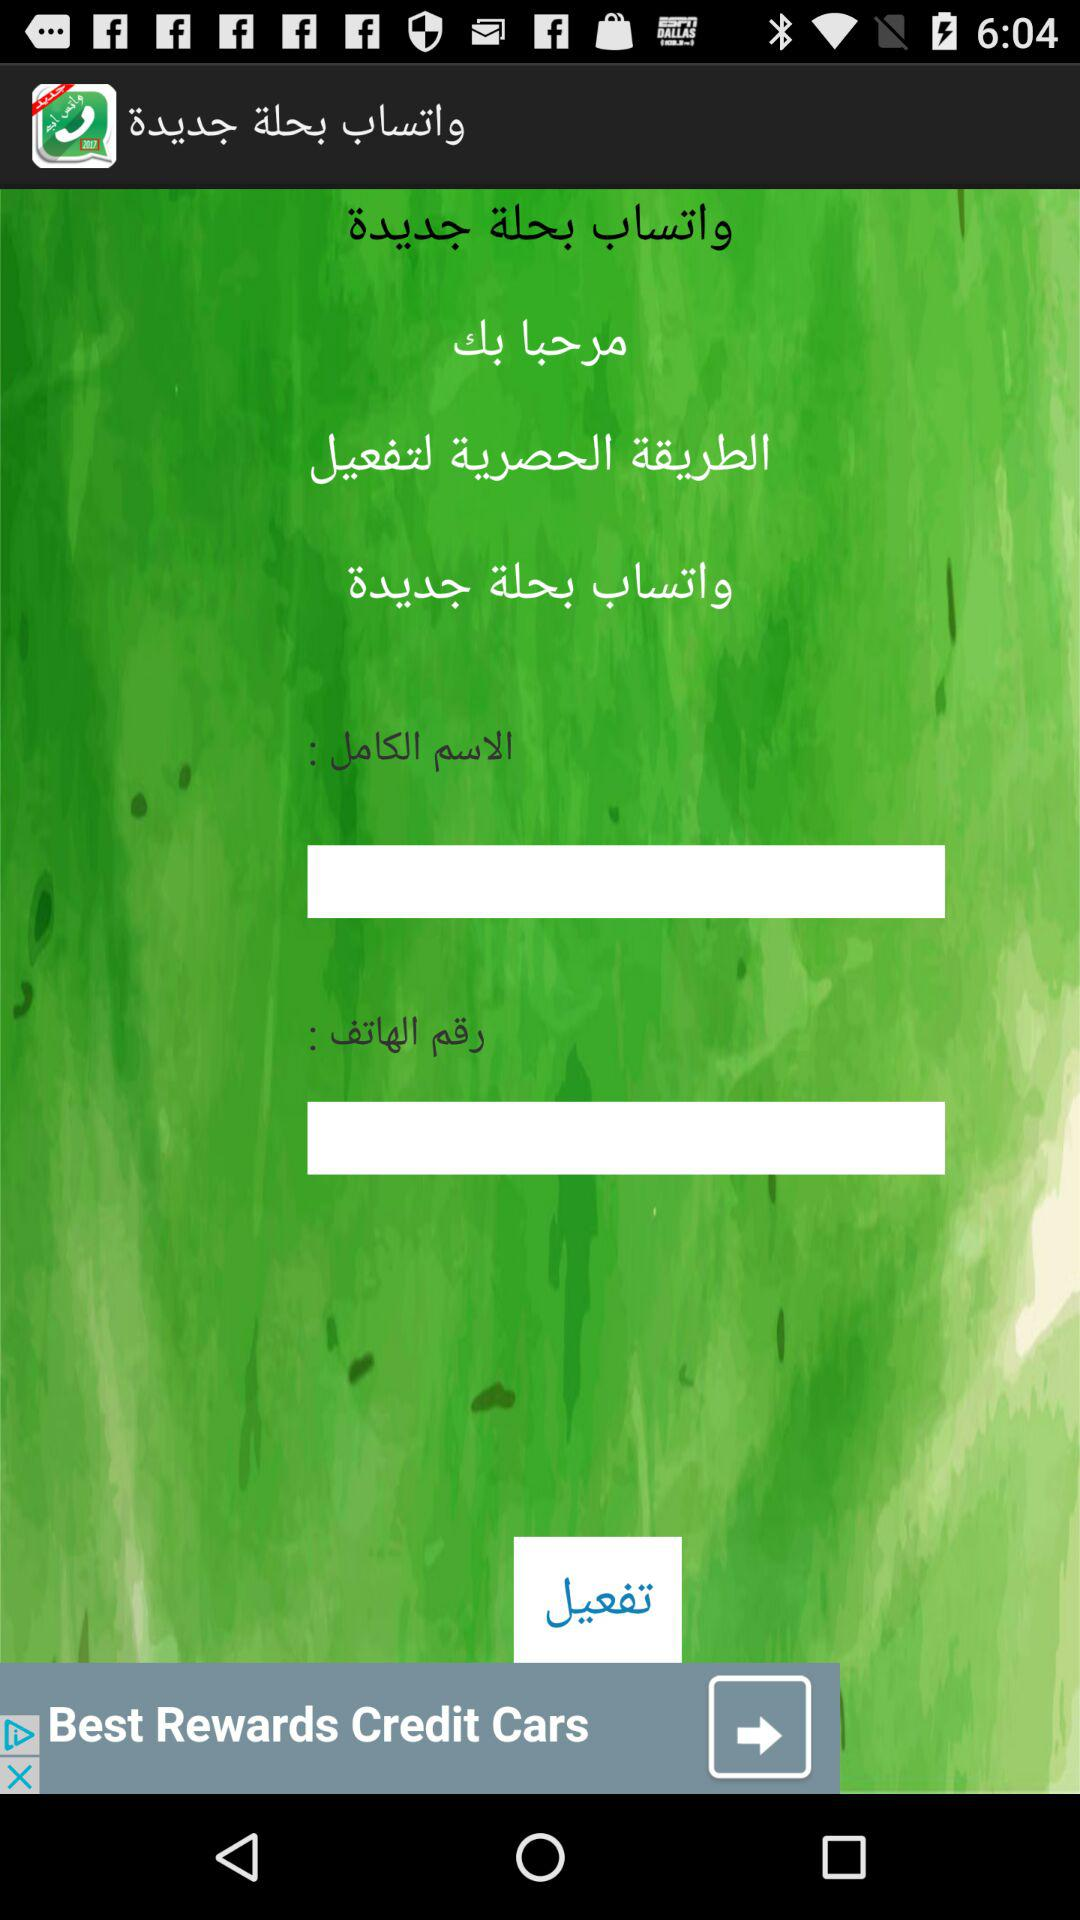How many text inputs are on the screen?
Answer the question using a single word or phrase. 2 